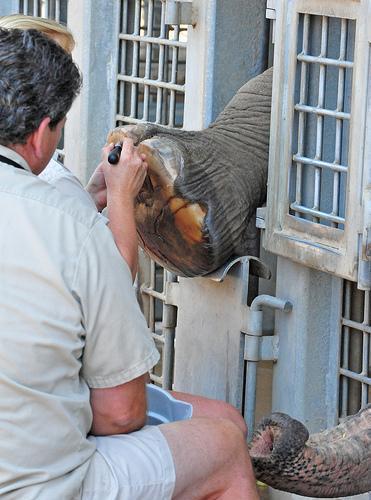How many people are there?
Give a very brief answer. 1. 